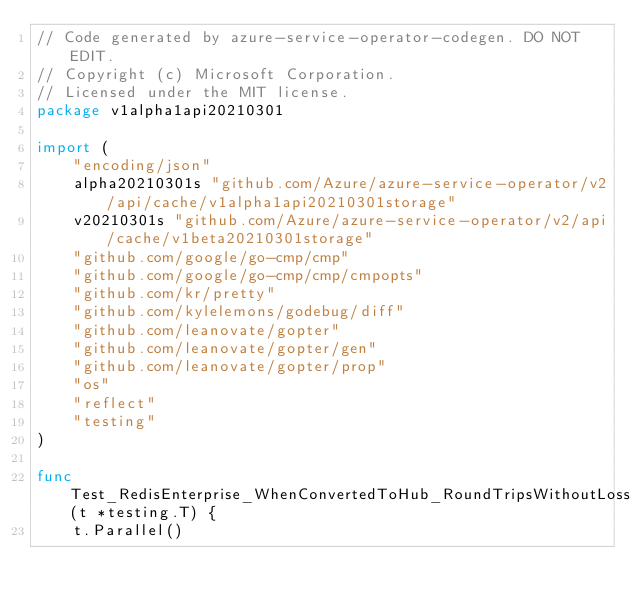<code> <loc_0><loc_0><loc_500><loc_500><_Go_>// Code generated by azure-service-operator-codegen. DO NOT EDIT.
// Copyright (c) Microsoft Corporation.
// Licensed under the MIT license.
package v1alpha1api20210301

import (
	"encoding/json"
	alpha20210301s "github.com/Azure/azure-service-operator/v2/api/cache/v1alpha1api20210301storage"
	v20210301s "github.com/Azure/azure-service-operator/v2/api/cache/v1beta20210301storage"
	"github.com/google/go-cmp/cmp"
	"github.com/google/go-cmp/cmp/cmpopts"
	"github.com/kr/pretty"
	"github.com/kylelemons/godebug/diff"
	"github.com/leanovate/gopter"
	"github.com/leanovate/gopter/gen"
	"github.com/leanovate/gopter/prop"
	"os"
	"reflect"
	"testing"
)

func Test_RedisEnterprise_WhenConvertedToHub_RoundTripsWithoutLoss(t *testing.T) {
	t.Parallel()</code> 